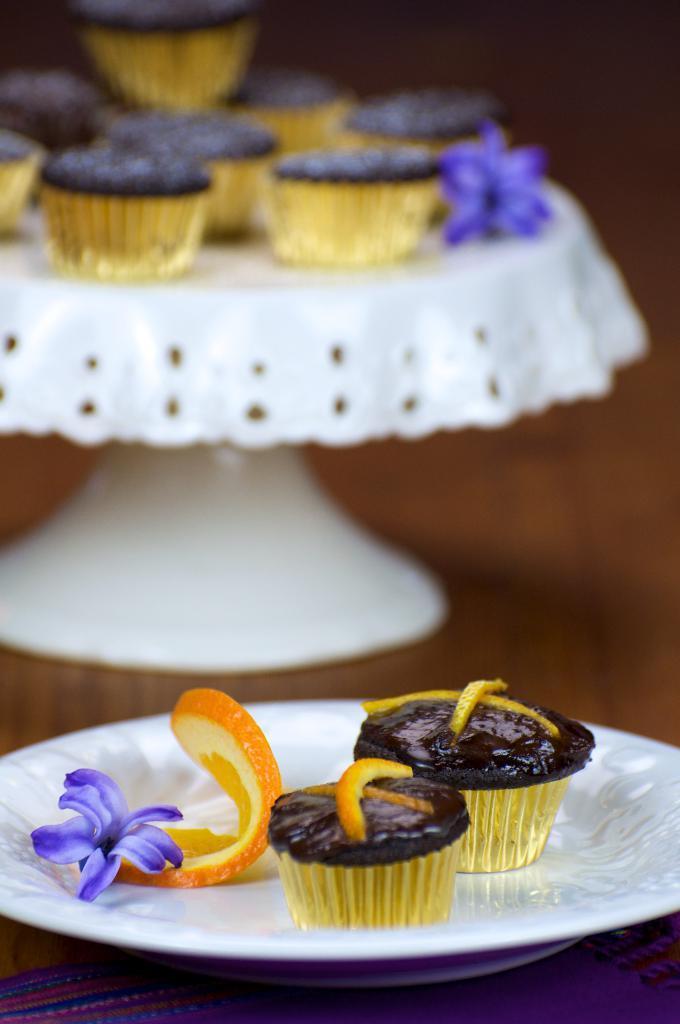How would you summarize this image in a sentence or two? In this picture I can see few muffins and a flower on the cake stand and couple of muffins and a flower and a orange slice in the plate on the table. 